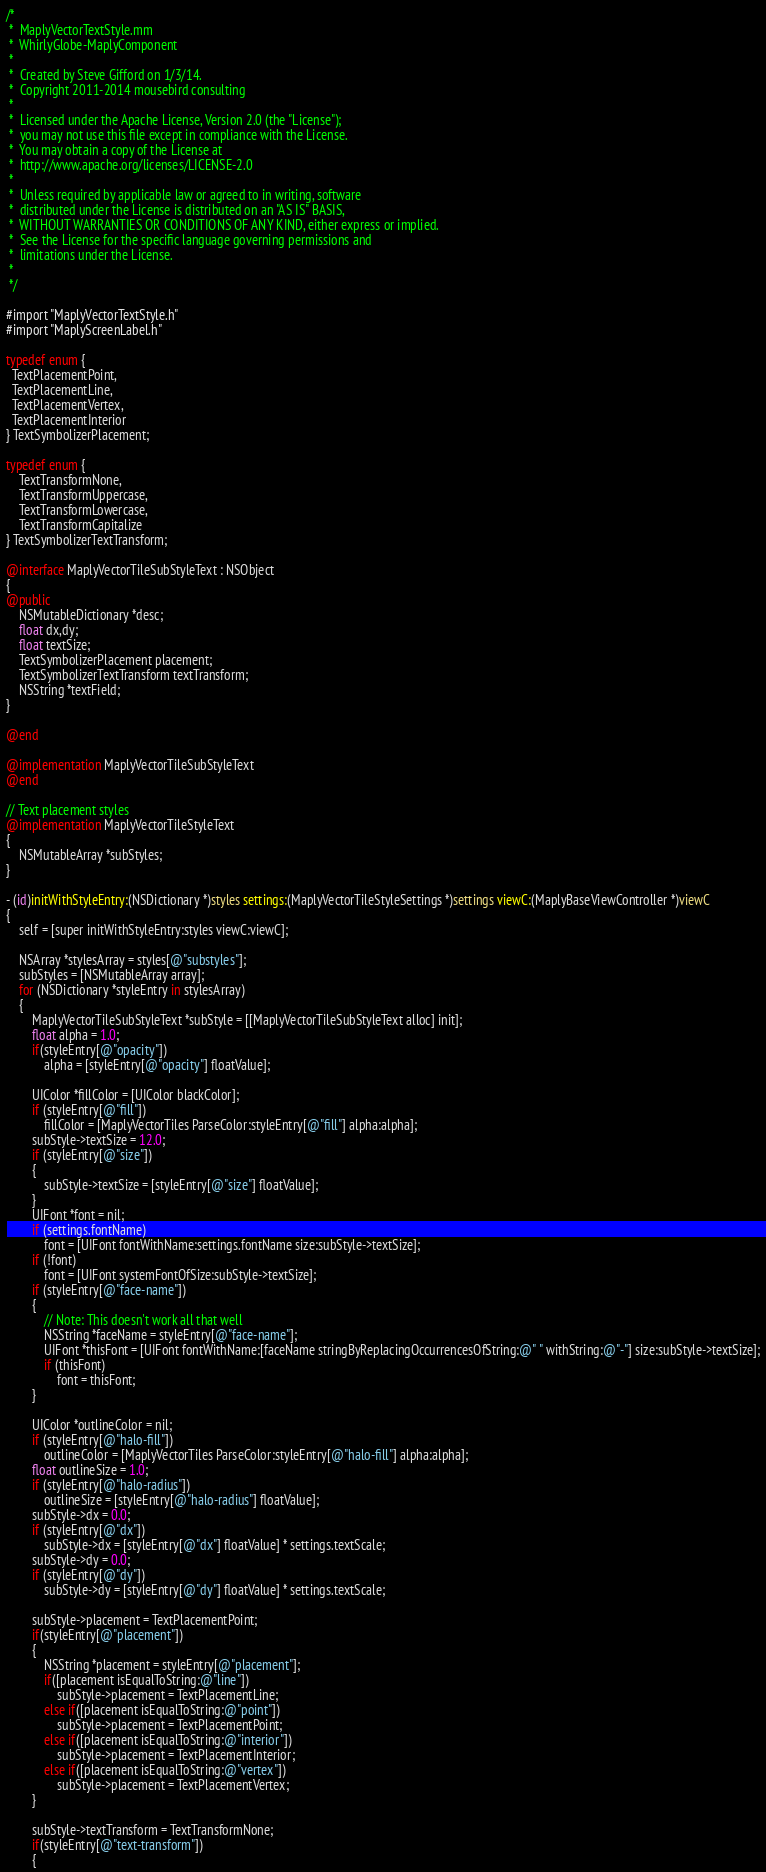<code> <loc_0><loc_0><loc_500><loc_500><_ObjectiveC_>/*
 *  MaplyVectorTextStyle.mm
 *  WhirlyGlobe-MaplyComponent
 *
 *  Created by Steve Gifford on 1/3/14.
 *  Copyright 2011-2014 mousebird consulting
 *
 *  Licensed under the Apache License, Version 2.0 (the "License");
 *  you may not use this file except in compliance with the License.
 *  You may obtain a copy of the License at
 *  http://www.apache.org/licenses/LICENSE-2.0
 *
 *  Unless required by applicable law or agreed to in writing, software
 *  distributed under the License is distributed on an "AS IS" BASIS,
 *  WITHOUT WARRANTIES OR CONDITIONS OF ANY KIND, either express or implied.
 *  See the License for the specific language governing permissions and
 *  limitations under the License.
 *
 */

#import "MaplyVectorTextStyle.h"
#import "MaplyScreenLabel.h"

typedef enum {
  TextPlacementPoint,
  TextPlacementLine,
  TextPlacementVertex,
  TextPlacementInterior
} TextSymbolizerPlacement;

typedef enum {
    TextTransformNone,
    TextTransformUppercase,
    TextTransformLowercase,
    TextTransformCapitalize
} TextSymbolizerTextTransform;

@interface MaplyVectorTileSubStyleText : NSObject
{
@public
    NSMutableDictionary *desc;
    float dx,dy;
    float textSize;
    TextSymbolizerPlacement placement;
    TextSymbolizerTextTransform textTransform;
    NSString *textField;
}

@end

@implementation MaplyVectorTileSubStyleText
@end

// Text placement styles
@implementation MaplyVectorTileStyleText
{
    NSMutableArray *subStyles;
}

- (id)initWithStyleEntry:(NSDictionary *)styles settings:(MaplyVectorTileStyleSettings *)settings viewC:(MaplyBaseViewController *)viewC
{
    self = [super initWithStyleEntry:styles viewC:viewC];

    NSArray *stylesArray = styles[@"substyles"];
    subStyles = [NSMutableArray array];
    for (NSDictionary *styleEntry in stylesArray)
    {
        MaplyVectorTileSubStyleText *subStyle = [[MaplyVectorTileSubStyleText alloc] init];
        float alpha = 1.0;
        if(styleEntry[@"opacity"])
            alpha = [styleEntry[@"opacity"] floatValue];
        
        UIColor *fillColor = [UIColor blackColor];
        if (styleEntry[@"fill"])
            fillColor = [MaplyVectorTiles ParseColor:styleEntry[@"fill"] alpha:alpha];
        subStyle->textSize = 12.0;
        if (styleEntry[@"size"])
        {
            subStyle->textSize = [styleEntry[@"size"] floatValue];
        }
        UIFont *font = nil;
        if (settings.fontName)
            font = [UIFont fontWithName:settings.fontName size:subStyle->textSize];
        if (!font)
            font = [UIFont systemFontOfSize:subStyle->textSize];
        if (styleEntry[@"face-name"])
        {
            // Note: This doesn't work all that well
            NSString *faceName = styleEntry[@"face-name"];
            UIFont *thisFont = [UIFont fontWithName:[faceName stringByReplacingOccurrencesOfString:@" " withString:@"-"] size:subStyle->textSize];
            if (thisFont)
                font = thisFont;
        }
        
        UIColor *outlineColor = nil;
        if (styleEntry[@"halo-fill"])
            outlineColor = [MaplyVectorTiles ParseColor:styleEntry[@"halo-fill"] alpha:alpha];
        float outlineSize = 1.0;
        if (styleEntry[@"halo-radius"])
            outlineSize = [styleEntry[@"halo-radius"] floatValue];
        subStyle->dx = 0.0;
        if (styleEntry[@"dx"])
            subStyle->dx = [styleEntry[@"dx"] floatValue] * settings.textScale;
        subStyle->dy = 0.0;
        if (styleEntry[@"dy"])
            subStyle->dy = [styleEntry[@"dy"] floatValue] * settings.textScale;
        
        subStyle->placement = TextPlacementPoint;
        if(styleEntry[@"placement"])
        {
            NSString *placement = styleEntry[@"placement"];
            if([placement isEqualToString:@"line"])
                subStyle->placement = TextPlacementLine;
            else if([placement isEqualToString:@"point"])
                subStyle->placement = TextPlacementPoint;
            else if([placement isEqualToString:@"interior"])
                subStyle->placement = TextPlacementInterior;
            else if([placement isEqualToString:@"vertex"])
                subStyle->placement = TextPlacementVertex;
        }
        
        subStyle->textTransform = TextTransformNone;
        if(styleEntry[@"text-transform"])
        {</code> 